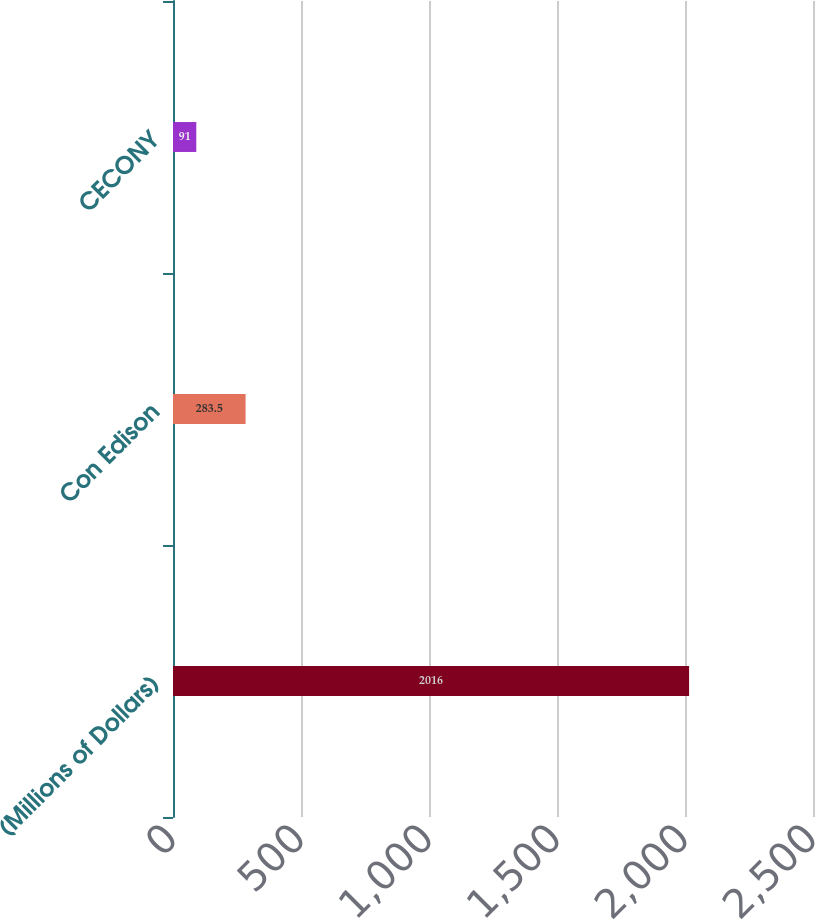<chart> <loc_0><loc_0><loc_500><loc_500><bar_chart><fcel>(Millions of Dollars)<fcel>Con Edison<fcel>CECONY<nl><fcel>2016<fcel>283.5<fcel>91<nl></chart> 